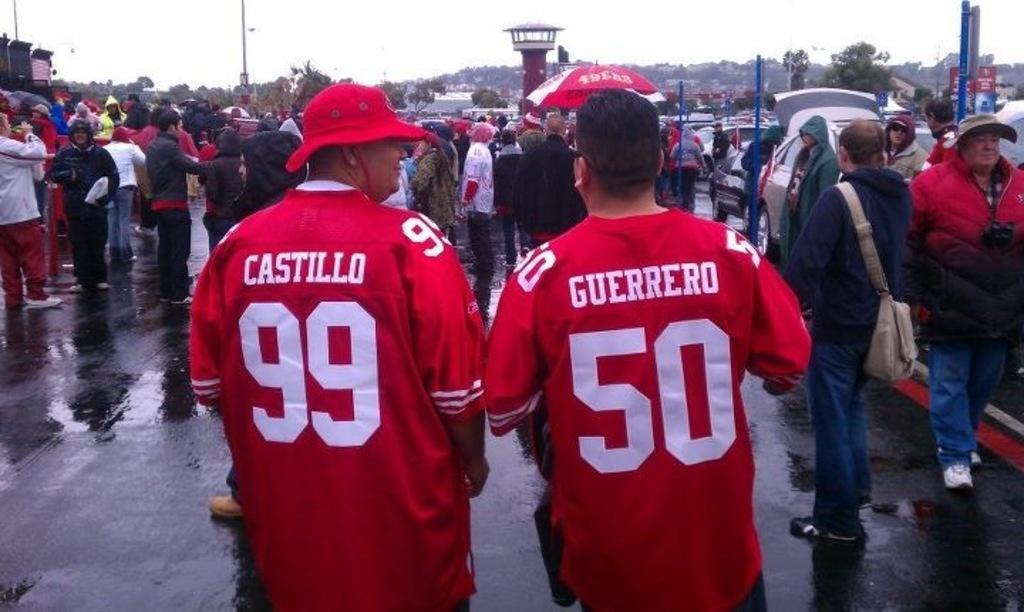<image>
Describe the image concisely. A group of people are standing in the rain and two men have red jerseys on that have numbers 99 and 50 on them. 